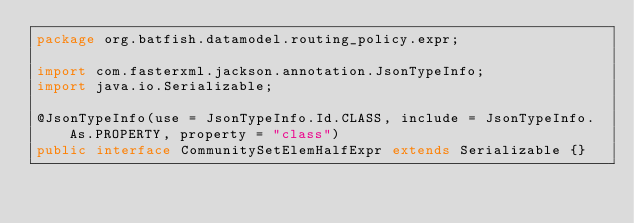<code> <loc_0><loc_0><loc_500><loc_500><_Java_>package org.batfish.datamodel.routing_policy.expr;

import com.fasterxml.jackson.annotation.JsonTypeInfo;
import java.io.Serializable;

@JsonTypeInfo(use = JsonTypeInfo.Id.CLASS, include = JsonTypeInfo.As.PROPERTY, property = "class")
public interface CommunitySetElemHalfExpr extends Serializable {}
</code> 